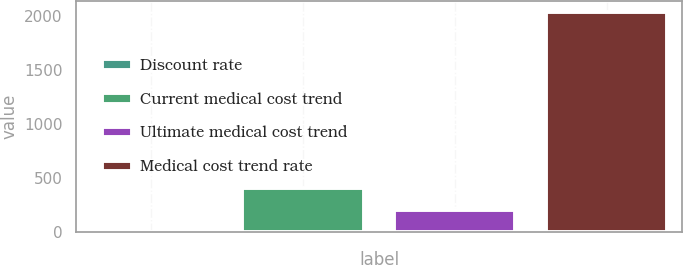<chart> <loc_0><loc_0><loc_500><loc_500><bar_chart><fcel>Discount rate<fcel>Current medical cost trend<fcel>Ultimate medical cost trend<fcel>Medical cost trend rate<nl><fcel>4.2<fcel>409.36<fcel>206.78<fcel>2030<nl></chart> 